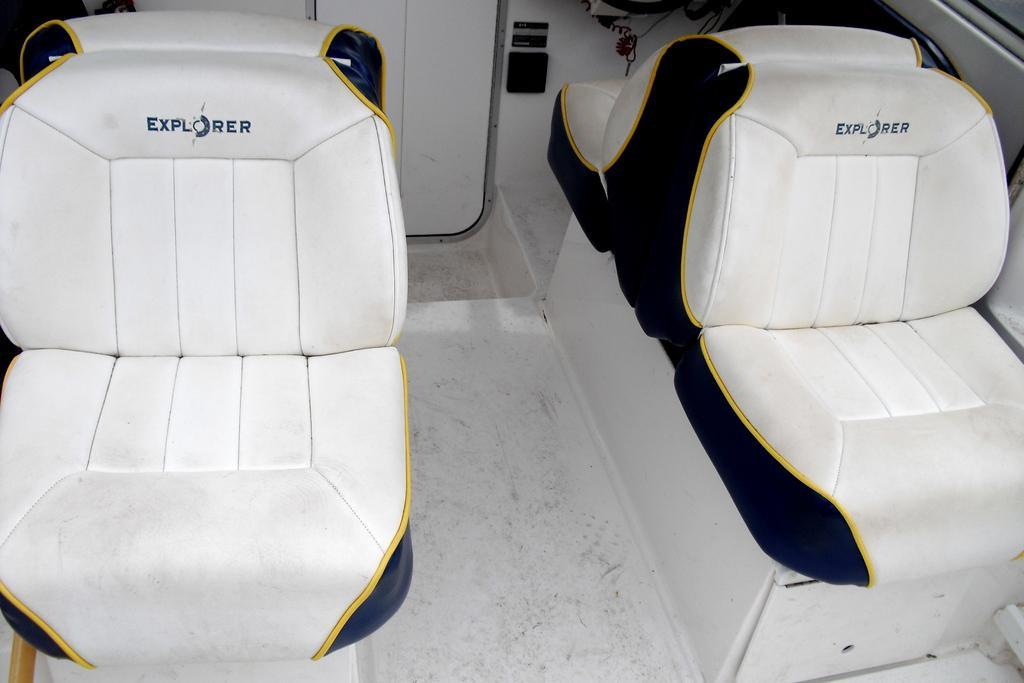Can you describe this image briefly? In this image I can see four white colour seats and in the front I can see something is written on it. In the background I can see two white colour things. 